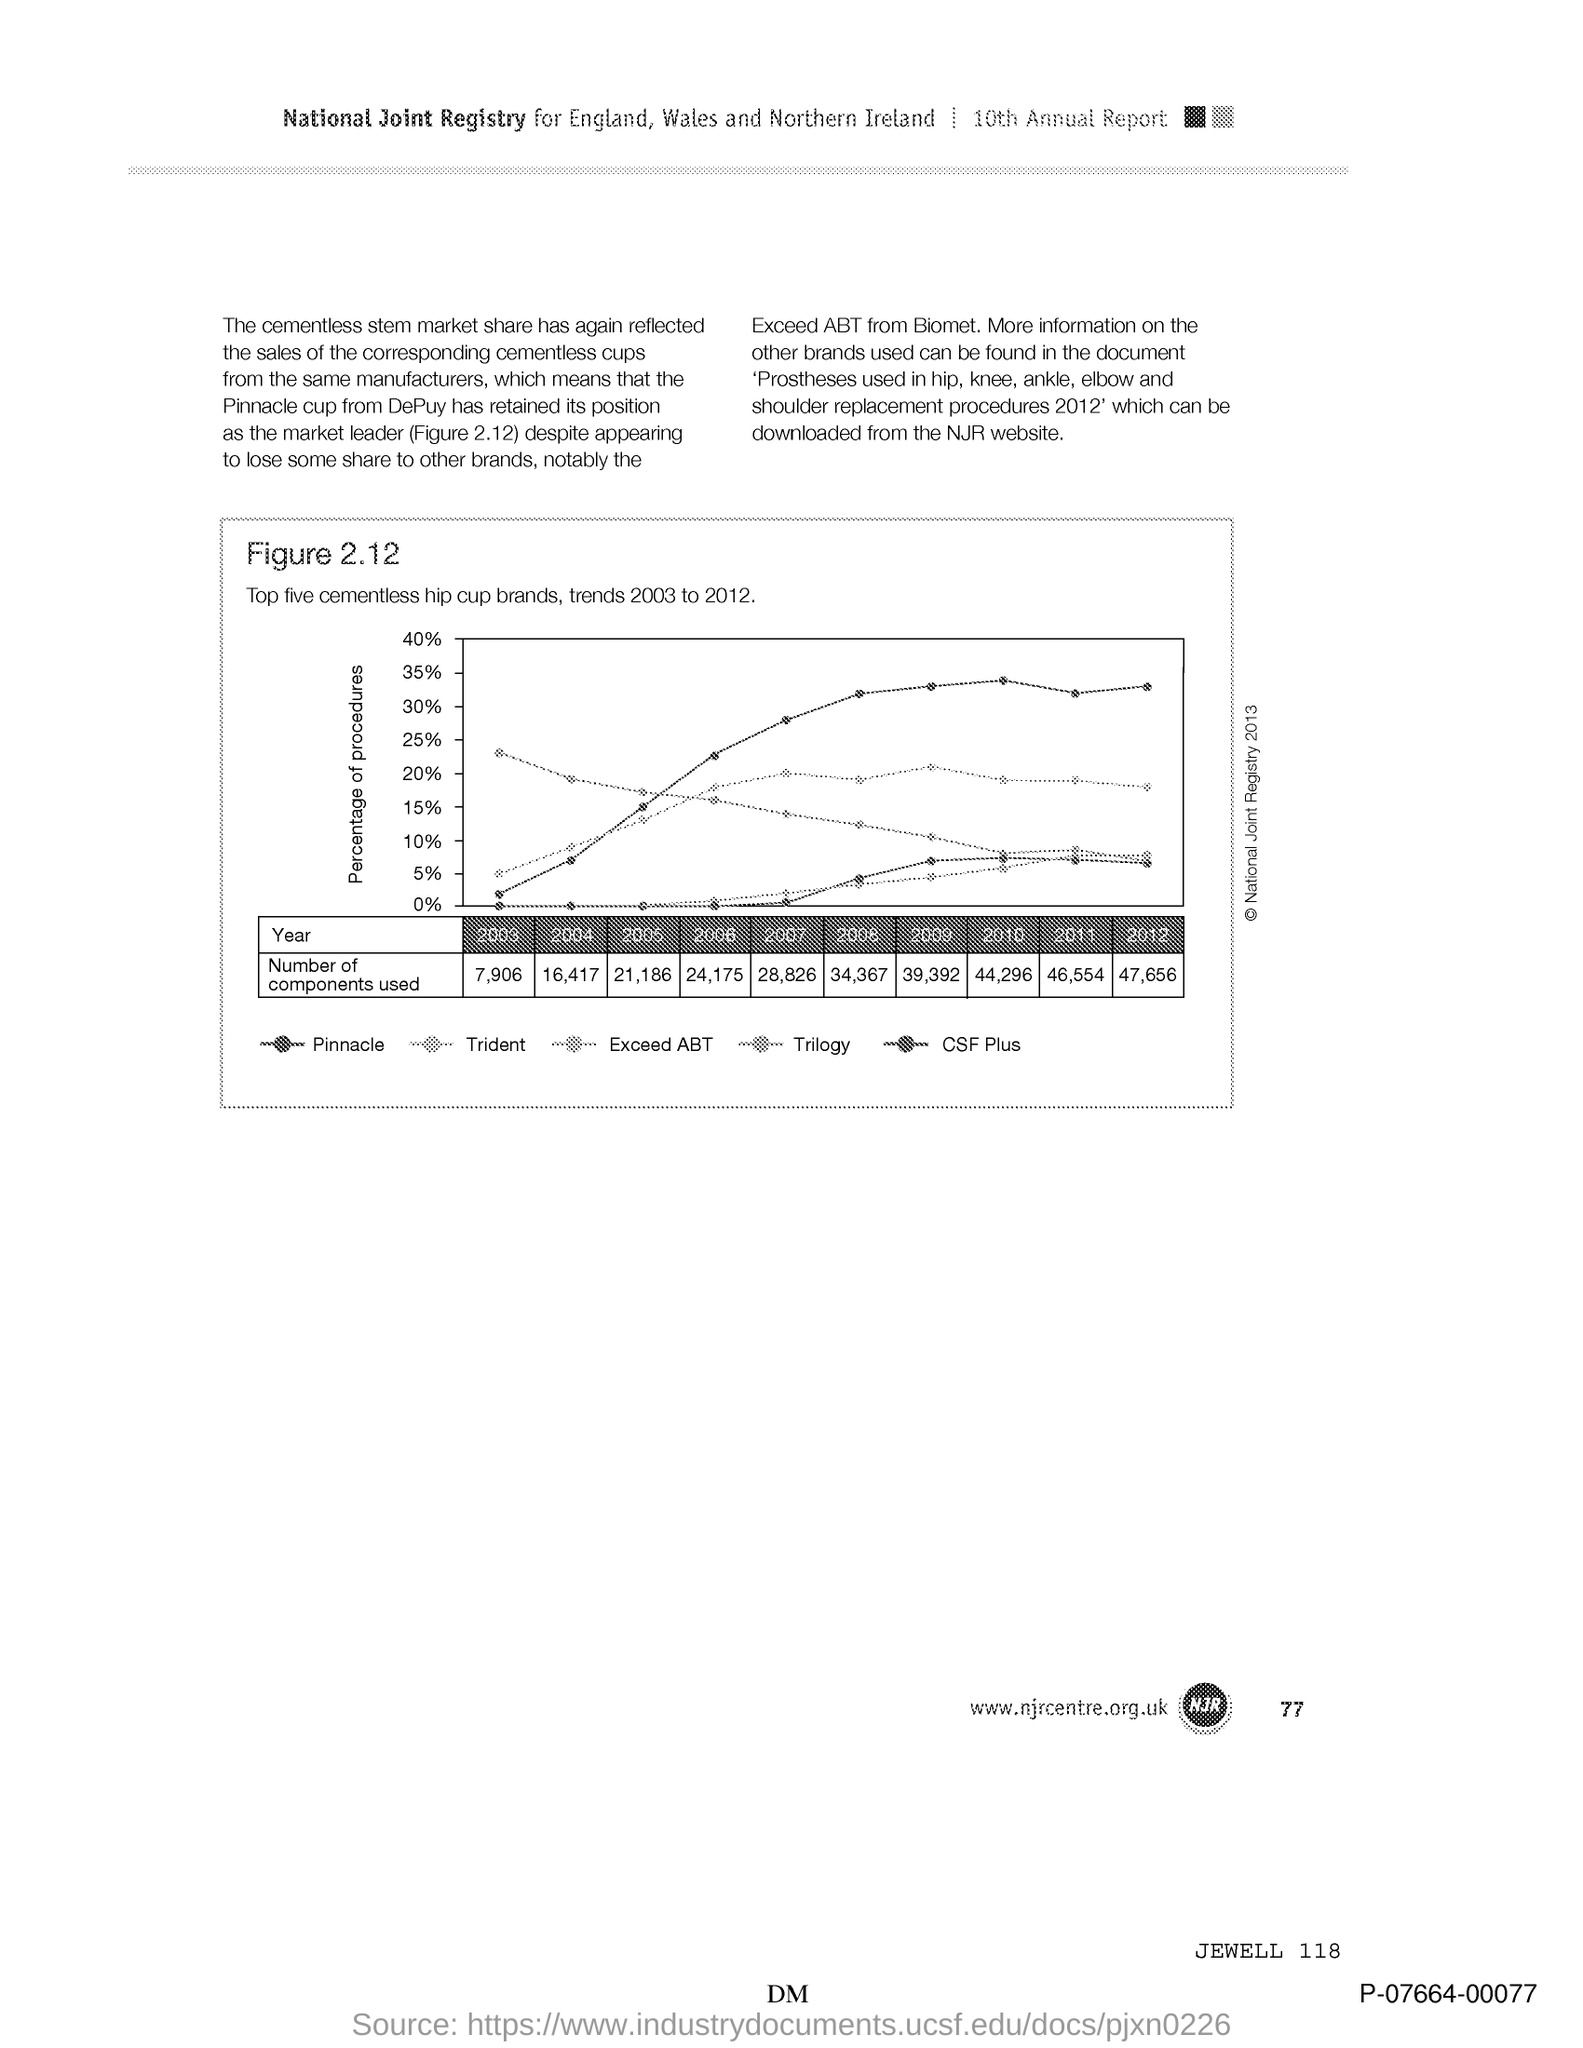Draw attention to some important aspects in this diagram. The page number is 77. 